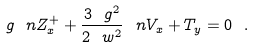Convert formula to latex. <formula><loc_0><loc_0><loc_500><loc_500>\ g \ n Z ^ { + } _ { x } + \frac { 3 \ g ^ { 2 } } { 2 \ w ^ { 2 } } \ n V _ { x } + T _ { y } = 0 \ .</formula> 